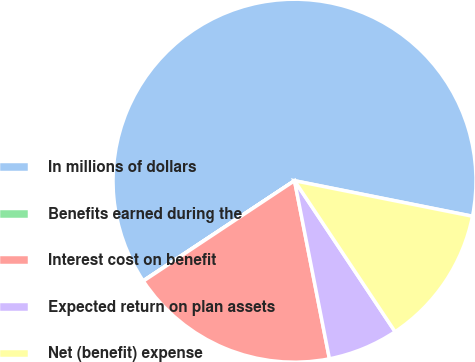<chart> <loc_0><loc_0><loc_500><loc_500><pie_chart><fcel>In millions of dollars<fcel>Benefits earned during the<fcel>Interest cost on benefit<fcel>Expected return on plan assets<fcel>Net (benefit) expense<nl><fcel>62.43%<fcel>0.03%<fcel>18.75%<fcel>6.27%<fcel>12.51%<nl></chart> 